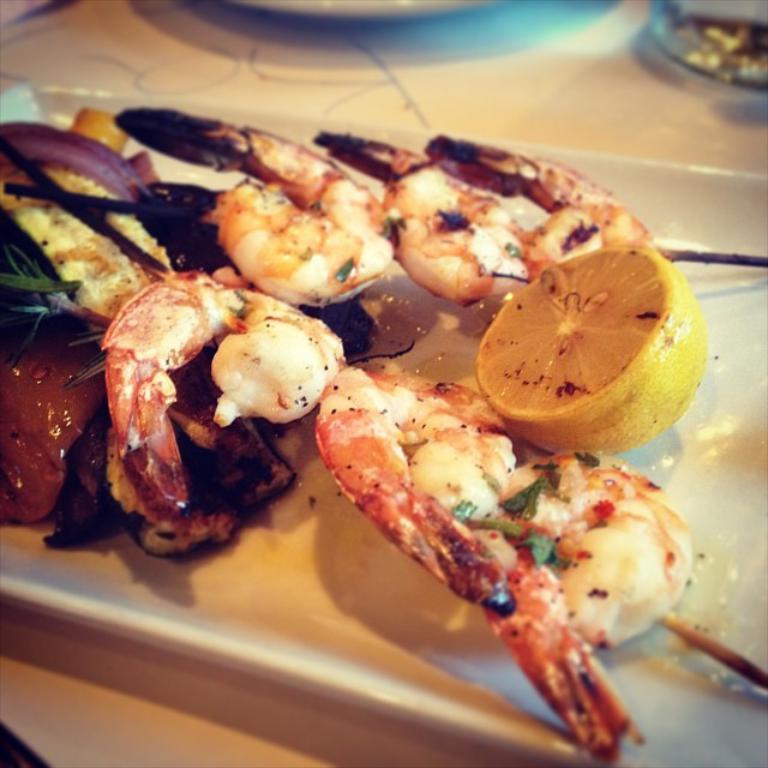Please provide a concise description of this image. In this image we can see king prawns, a slice of lemon placed on a plate, the plate is on top of a table. 